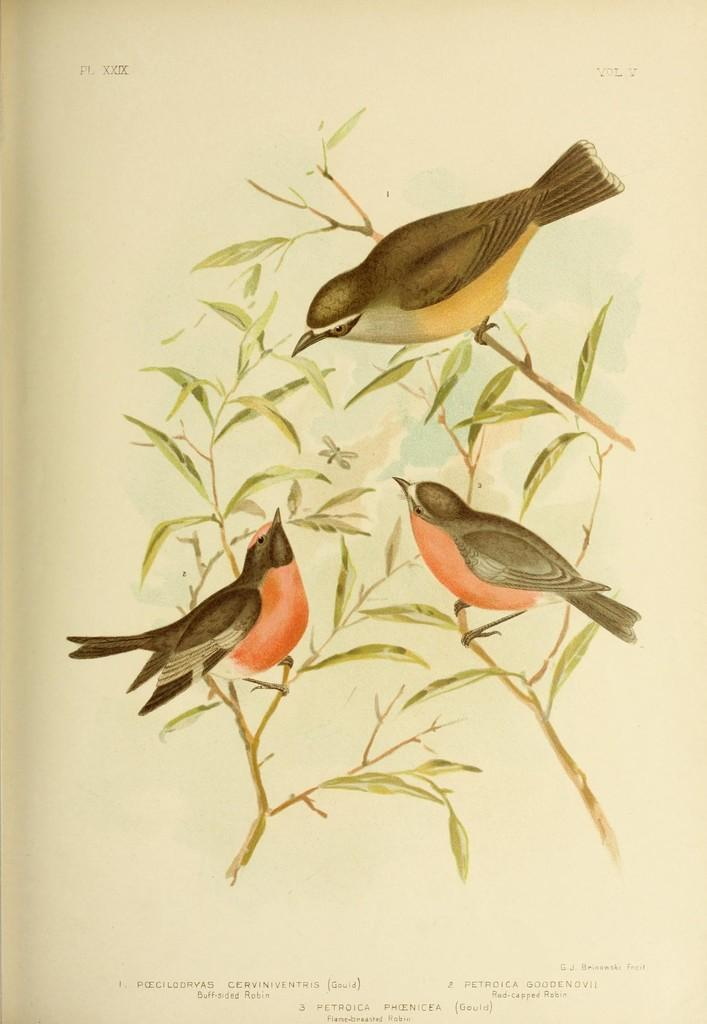What is depicted on the paper in the image? The paper has a drawing of birds on it. Can you describe the drawing in more detail? The drawing includes leaves along with the birds. What type of potato is being used as a stocking in the image? There is no potato or stocking present in the image; it only features a paper with a drawing of birds and leaves. 